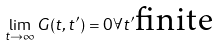<formula> <loc_0><loc_0><loc_500><loc_500>\lim _ { t \to \infty } G ( t , t ^ { \prime } ) = 0 \forall t ^ { \prime } \text {finite}</formula> 